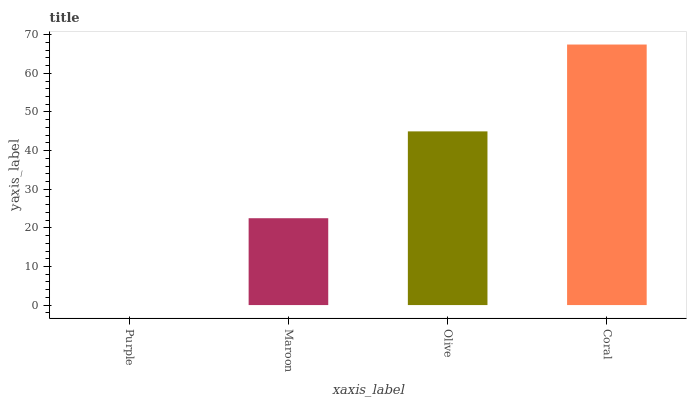Is Purple the minimum?
Answer yes or no. Yes. Is Coral the maximum?
Answer yes or no. Yes. Is Maroon the minimum?
Answer yes or no. No. Is Maroon the maximum?
Answer yes or no. No. Is Maroon greater than Purple?
Answer yes or no. Yes. Is Purple less than Maroon?
Answer yes or no. Yes. Is Purple greater than Maroon?
Answer yes or no. No. Is Maroon less than Purple?
Answer yes or no. No. Is Olive the high median?
Answer yes or no. Yes. Is Maroon the low median?
Answer yes or no. Yes. Is Maroon the high median?
Answer yes or no. No. Is Purple the low median?
Answer yes or no. No. 